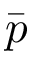<formula> <loc_0><loc_0><loc_500><loc_500>\bar { p }</formula> 